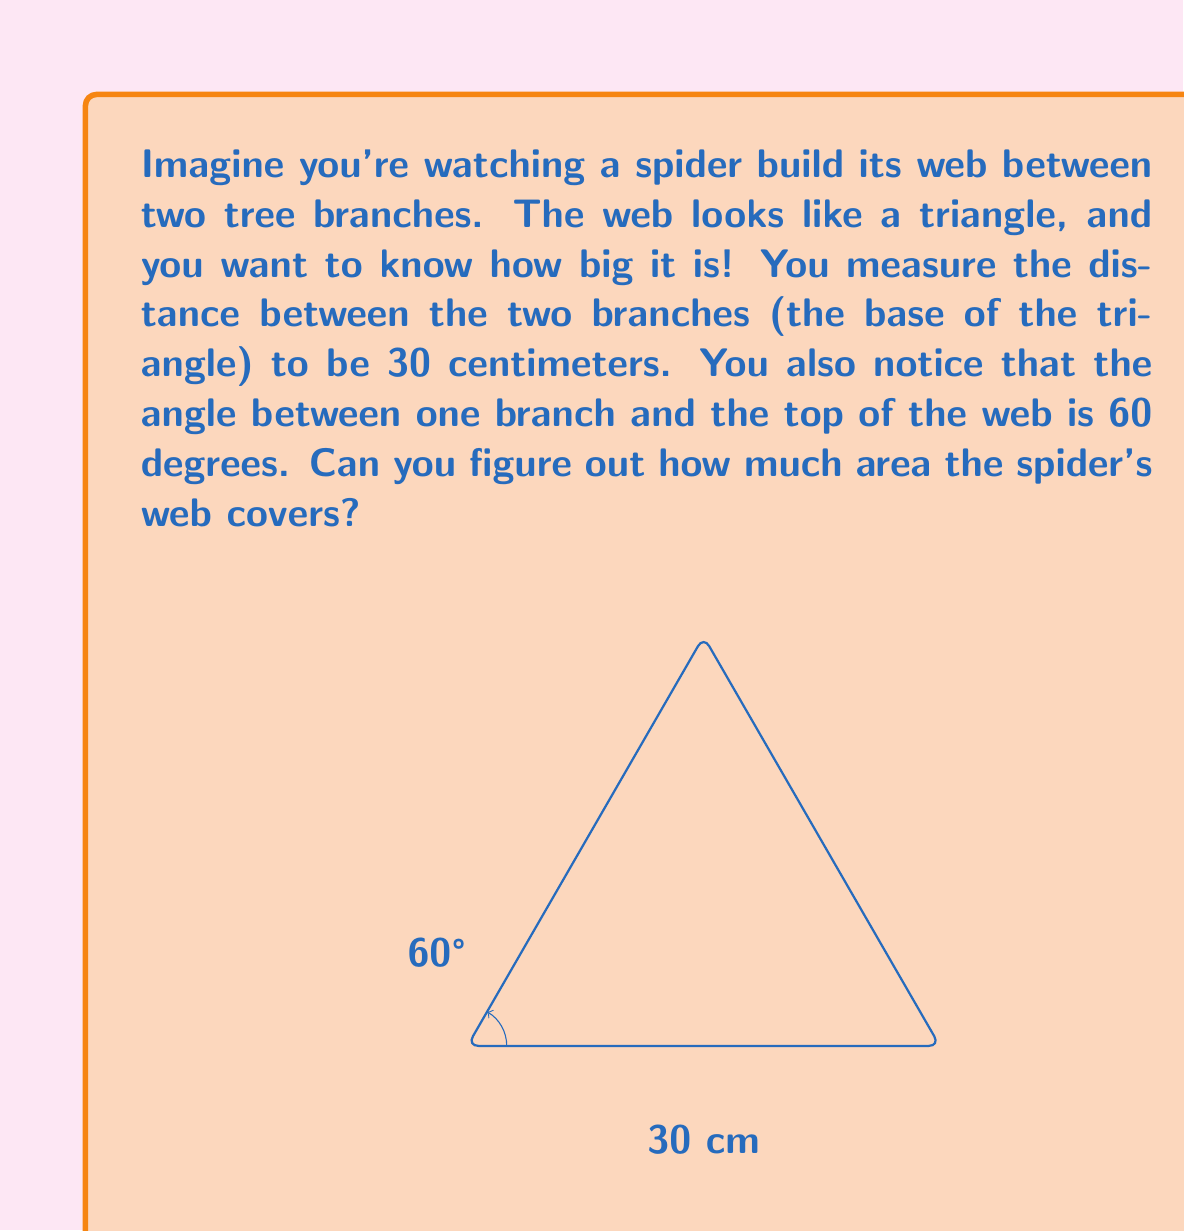Show me your answer to this math problem. Let's break this down step by step:

1) First, we need to understand what we know:
   - The base of the triangle (distance between branches) is 30 cm
   - One of the angles is 60°

2) In a triangle, we can use trigonometry to find the height. The height will be perpendicular to the base, creating a right triangle.

3) In this right triangle:
   - The angle we know is 60°
   - The side adjacent to this angle is half of the base (15 cm)
   - We want to find the opposite side, which is the height of the original triangle

4) We can use the tangent function for this:

   $\tan(60°) = \frac{\text{opposite}}{\text{adjacent}} = \frac{\text{height}}{15}$

5) We know that $\tan(60°) = \sqrt{3}$, so:

   $\sqrt{3} = \frac{\text{height}}{15}$

6) Solving for height:

   $\text{height} = 15\sqrt{3}$ cm

7) Now that we have the base (30 cm) and height $(15\sqrt{3}$ cm), we can calculate the area of the triangle using the formula:

   $\text{Area} = \frac{1}{2} \times \text{base} \times \text{height}$

8) Plugging in our values:

   $\text{Area} = \frac{1}{2} \times 30 \times 15\sqrt{3}$

9) Simplifying:

   $\text{Area} = 225\sqrt{3}$ sq cm

This is the exact area, but since we're estimating, we can round it to a whole number:

$225\sqrt{3} \approx 390$ sq cm
Answer: The spider's web covers approximately 390 square centimeters. 